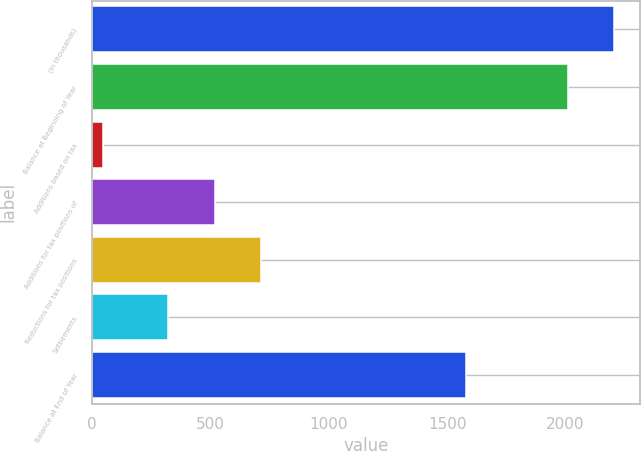Convert chart to OTSL. <chart><loc_0><loc_0><loc_500><loc_500><bar_chart><fcel>(in thousands)<fcel>Balance at Beginning of Year<fcel>Additions based on tax<fcel>Additions for tax positions of<fcel>Reductions for tax positions<fcel>Settlements<fcel>Balance at End of Year<nl><fcel>2205.7<fcel>2009<fcel>45<fcel>518.7<fcel>715.4<fcel>322<fcel>1581<nl></chart> 